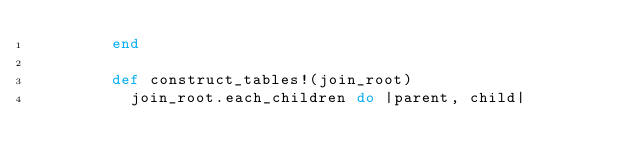Convert code to text. <code><loc_0><loc_0><loc_500><loc_500><_Ruby_>        end

        def construct_tables!(join_root)
          join_root.each_children do |parent, child|</code> 